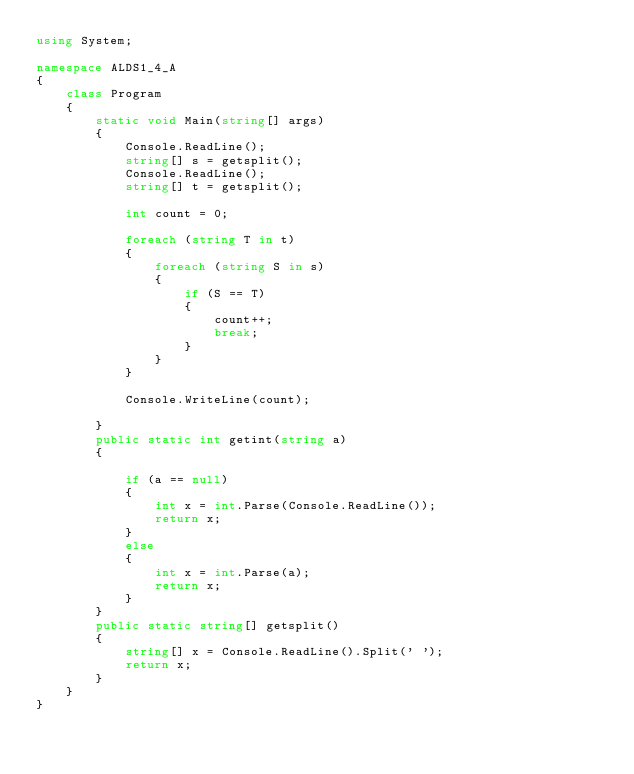<code> <loc_0><loc_0><loc_500><loc_500><_C#_>using System;

namespace ALDS1_4_A
{
    class Program
    {
        static void Main(string[] args)
        {
            Console.ReadLine();
            string[] s = getsplit();
            Console.ReadLine();
            string[] t = getsplit();
            
            int count = 0;

            foreach (string T in t)
            {
                foreach (string S in s)
                {
                    if (S == T)
                    {
                        count++;
                        break;
                    }
                }
            }
        
            Console.WriteLine(count);

        }
        public static int getint(string a)
        {

            if (a == null)
            {
                int x = int.Parse(Console.ReadLine());
                return x;
            }
            else
            {
                int x = int.Parse(a);
                return x;
            }
        }
        public static string[] getsplit()
        {
            string[] x = Console.ReadLine().Split(' ');
            return x;
        }
    }
}</code> 